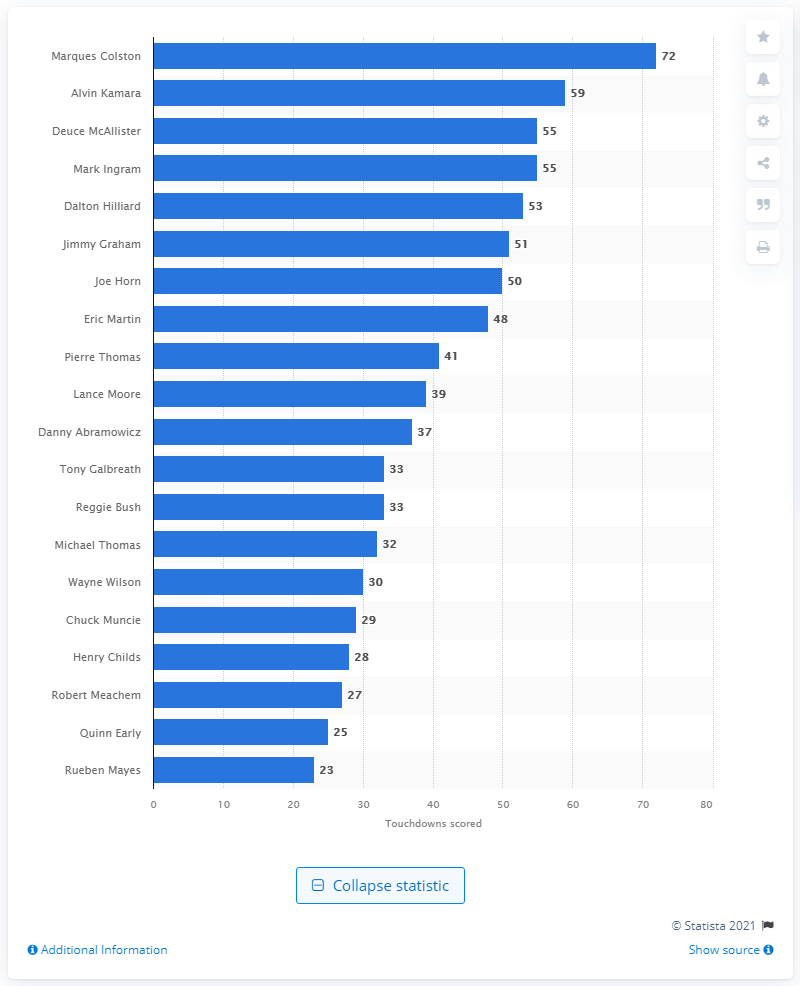List a handful of essential elements in this visual. Marques Colston is the career touchdown leader of the New Orleans Saints. Marques Colston, a player for the New Orleans Saints, has scored 72 career touchdowns. 